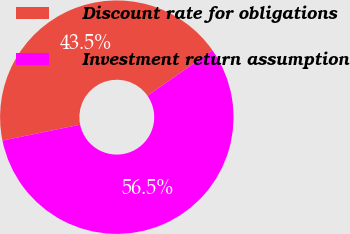<chart> <loc_0><loc_0><loc_500><loc_500><pie_chart><fcel>Discount rate for obligations<fcel>Investment return assumption<nl><fcel>43.52%<fcel>56.48%<nl></chart> 